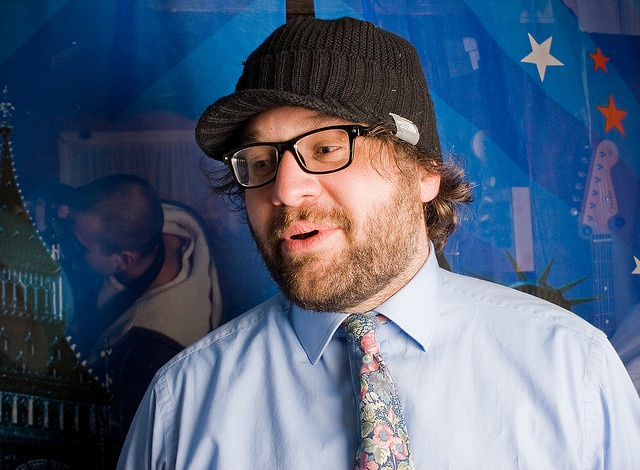Describe the objects in this image and their specific colors. I can see people in navy, lightgray, black, darkgray, and lightpink tones, people in navy, black, and gray tones, and tie in navy, lightgray, darkgray, lightpink, and gray tones in this image. 